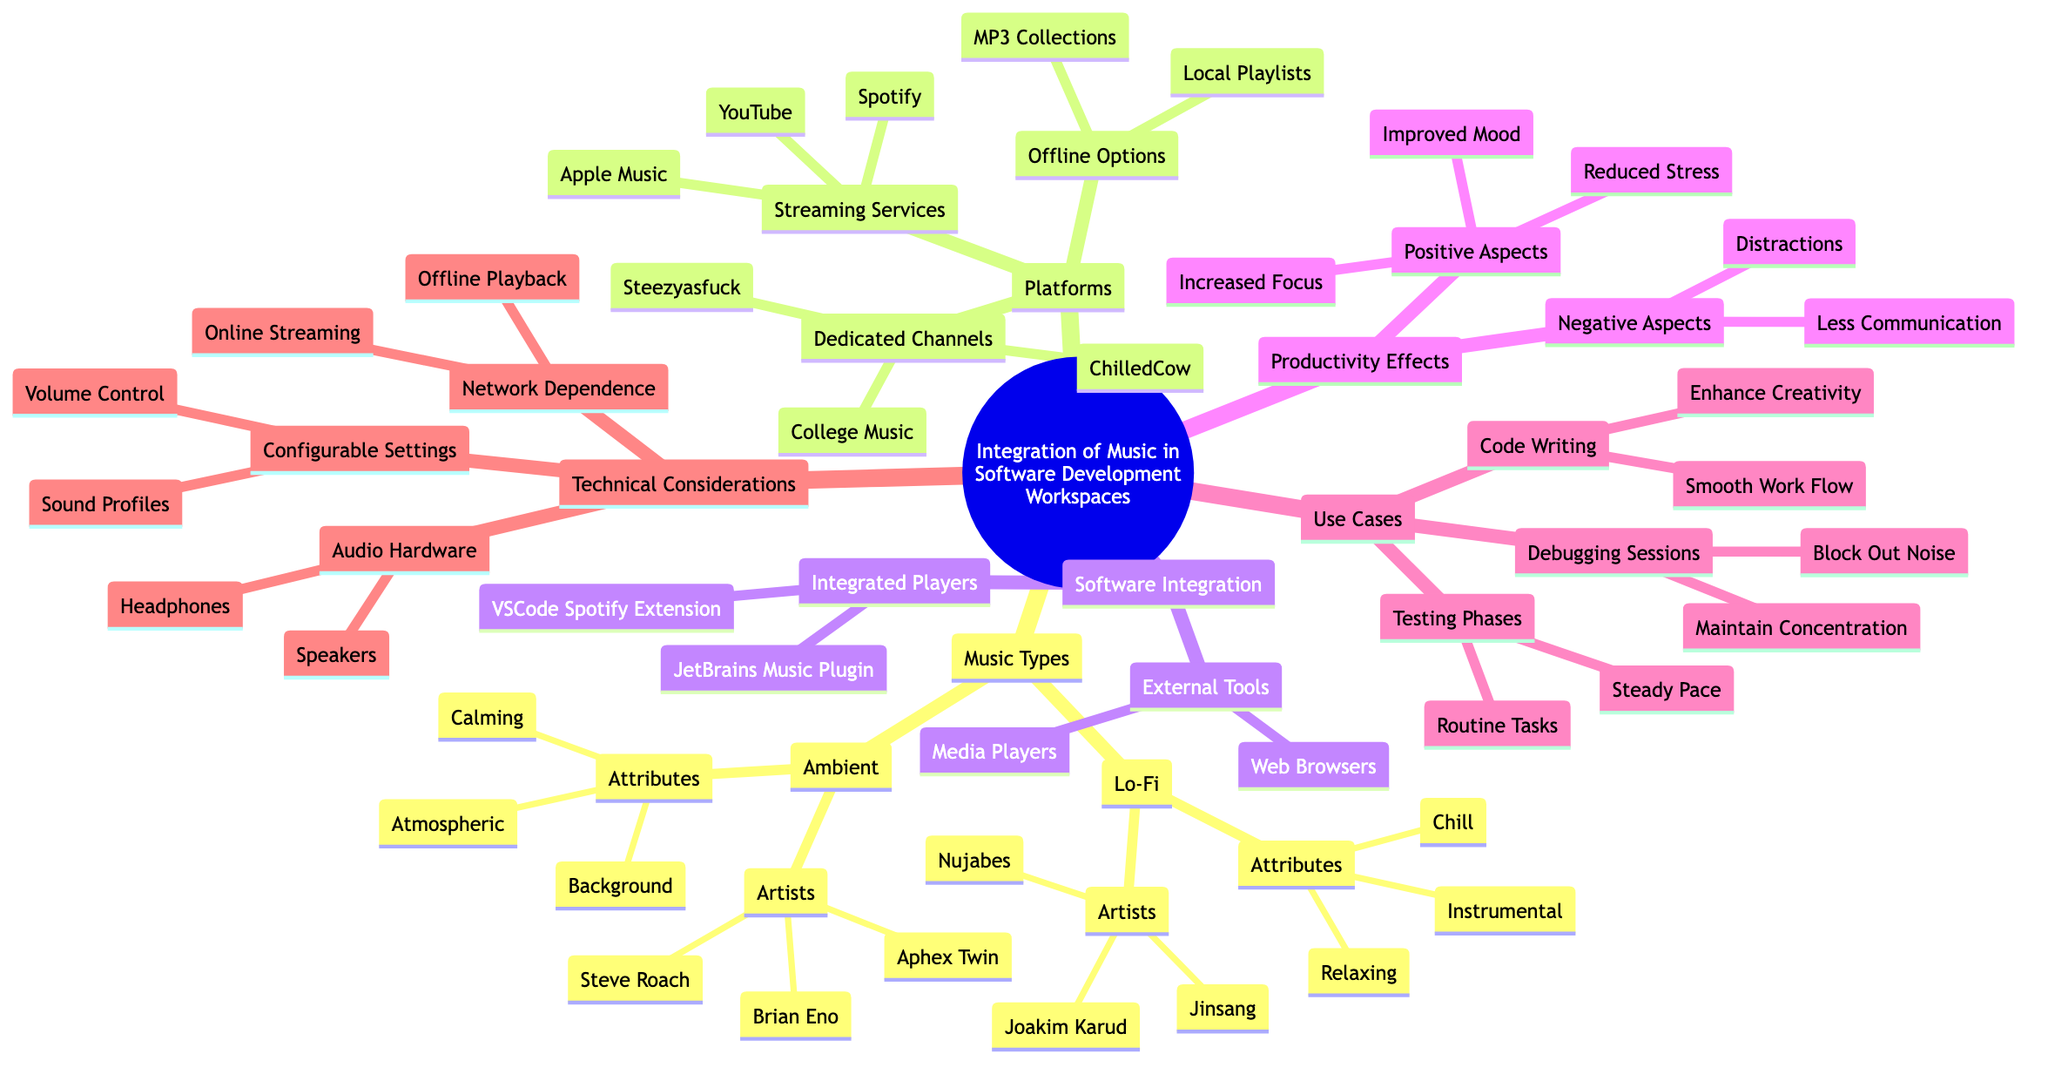What is one type of music mentioned under Music Types? The diagram lists two types of music: Lo-Fi and Ambient. Through observation, we can identify "Lo-Fi" as one specific type of music.
Answer: Lo-Fi How many artists are associated with Lo-Fi music? Under the Lo-Fi category, there are three artists mentioned: Nujabes, Jinsang, and Joakim Karud. Therefore, counting these gives us three artists.
Answer: 3 What is a positive aspect of integrating music into software development workspaces? Within the Productivity Effects section, "Increased Focus" is identified as one of the positive aspects of using music in the workspace.
Answer: Increased Focus Which platform offers offline options according to the diagram? In Platforms, "Offline Options" is explicitly listed, which includes "MP3 Collections" and "Local Playlists". This indicates that these options are available for offline use.
Answer: MP3 Collections Name an external tool mentioned in Software Integration. The Software Integration section lists "Media Players" and "Web Browsers" under External Tools. From these, we can select "Media Players" as one example.
Answer: Media Players What attribute is associated with Ambient music? Under Ambient, the attributes section lists "Calming," "Background," and "Atmospheric". Any of these attributes can be considered an answer.
Answer: Calming What is one use case for playing music during debugging sessions? The Use Cases section indicates that during Debugging Sessions, one of the goals is to "Maintain Concentration". This is a specific use case for music in that context.
Answer: Maintain Concentration How many attributes does Lo-Fi music have listed in the diagram? The attributes under Lo-Fi are "Chill," "Relaxing," and "Instrumental." This is a total of three attributes described for Lo-Fi music.
Answer: 3 What does "Network Dependence" pertain to in Technical Considerations? Network Dependence in Technical Considerations refers to two specific points: "Online Streaming" and "Offline Playback". This indicates how music can be dependent on network status.
Answer: Online Streaming 